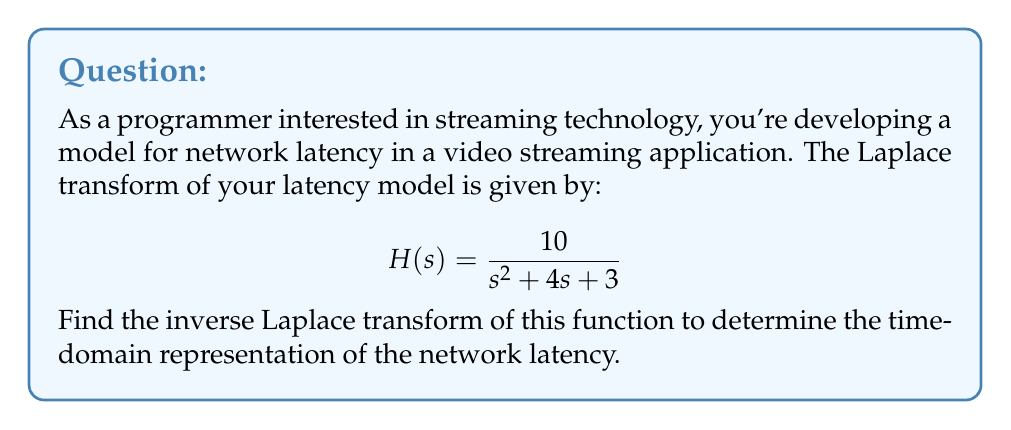Help me with this question. To find the inverse Laplace transform, we'll follow these steps:

1) First, we need to factor the denominator of $H(s)$:
   $$s^2 + 4s + 3 = (s + 1)(s + 3)$$

2) Now, we can express $H(s)$ in partial fraction decomposition form:
   $$H(s) = \frac{10}{(s + 1)(s + 3)} = \frac{A}{s + 1} + \frac{B}{s + 3}$$

3) To find A and B, we'll multiply both sides by $(s + 1)(s + 3)$:
   $$10 = A(s + 3) + B(s + 1)$$

4) Substituting $s = -1$ and $s = -3$:
   For $s = -1$: $10 = A(2)$, so $A = 5$
   For $s = -3$: $10 = B(-2)$, so $B = -5$

5) Therefore, our partial fraction decomposition is:
   $$H(s) = \frac{5}{s + 1} - \frac{5}{s + 3}$$

6) Now, we can use the linearity property of the inverse Laplace transform and the standard inverse Laplace transform formula:
   $$\mathcal{L}^{-1}\left\{\frac{1}{s + a}\right\} = e^{-at}$$

7) Applying this to our decomposed function:
   $$\mathcal{L}^{-1}\{H(s)\} = 5\mathcal{L}^{-1}\left\{\frac{1}{s + 1}\right\} - 5\mathcal{L}^{-1}\left\{\frac{1}{s + 3}\right\}$$
   $$= 5e^{-t} - 5e^{-3t}$$

This gives us the time-domain representation of the network latency model.
Answer: The inverse Laplace transform of $H(s) = \frac{10}{s^2 + 4s + 3}$ is:

$$h(t) = 5e^{-t} - 5e^{-3t}$$ 